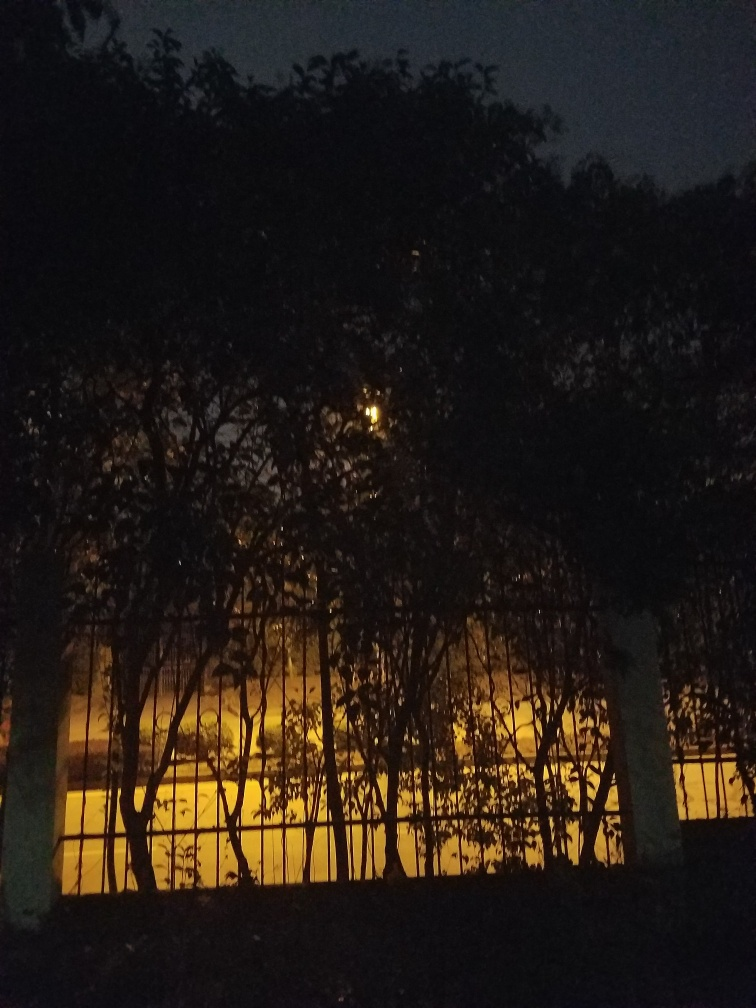What could be the light source behind the trees? The light source appears to be artificial, potentially street lighting or lights from a nearby building that cast a warm glow. Its radiance filtered through the trees creates interplay of light and shadow that might indicate the presence of a park or a street lined with trees adjacent to an illuminated area. 